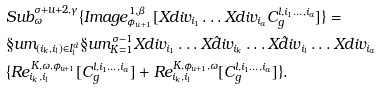<formula> <loc_0><loc_0><loc_500><loc_500>& S u b ^ { \sigma + u + 2 , \gamma } _ { \omega } \{ I m a g e ^ { 1 , \beta } _ { \phi _ { u + 1 } } [ X d i v _ { i _ { 1 } } \dots X d i v _ { i _ { a } } C ^ { l , i _ { 1 } \dots , i _ { a } } _ { g } ] \} = \\ & \S u m _ { ( i _ { k } , i _ { l } ) \in I ^ { d } _ { l } } \S u m _ { K = 1 } ^ { \sigma - 1 } X d i v _ { i _ { 1 } } \dots \hat { X d i v } _ { i _ { k } } \dots \hat { X d i v } _ { i _ { l } } \dots X d i v _ { i _ { a } } \\ & \{ R e ^ { K , \omega , \phi _ { u + 1 } } _ { i _ { k } , i _ { l } } [ C ^ { l , i _ { 1 } \dots , i _ { a } } _ { g } ] + R e ^ { K , \phi _ { u + 1 } , \omega } _ { i _ { k } , i _ { l } } [ C ^ { l , i _ { 1 } \dots , i _ { a } } _ { g } ] \} .</formula> 